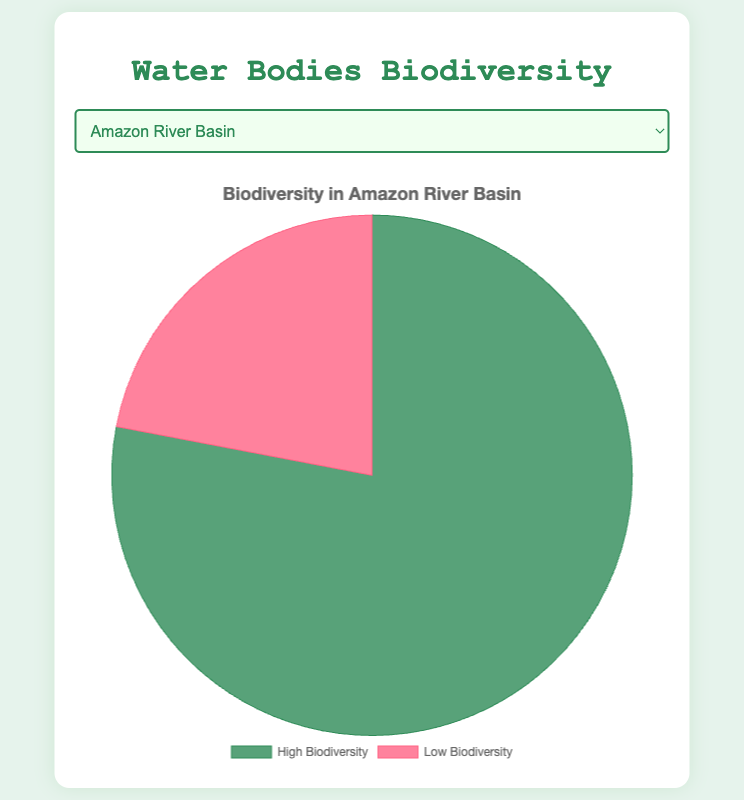Which water body has the highest percentage of high biodiversity? To determine this, compare the percentage of high biodiversity across all listed water bodies. The Coral Triangle has the highest percentage of high biodiversity at 89%.
Answer: Coral Triangle Which water bodies have less than 20% low biodiversity? Check the percentage of low biodiversity for each location. The Amazon River Basin, Great Barrier Reef, and Coral Triangle all have low biodiversity percentages under 20%.
Answer: Amazon River Basin, Great Barrier Reef, Coral Triangle How much higher is the percentage of high biodiversity in the Coral Triangle compared to the Mississippi River Delta? Subtract the percentage of high biodiversity in the Mississippi River Delta (52%) from that in the Coral Triangle (89%). The difference is 89% - 52% = 37%.
Answer: 37% What is the average percentage of high biodiversity across all water bodies? Add the percentages of high biodiversity for all locations and divide by the number of locations. (78% + 84% + 60% + 89% + 52%) / 5 = 72.6%.
Answer: 72.6% Which water body has the closest percentages of high and low biodiversity? The Mississippi River Delta has high biodiversity at 52% and low biodiversity at 48%, which are the closest in magnitude.
Answer: Mississippi River Delta Compare the sum of high biodiversity percentages in the Amazon River Basin and the Coral Triangle to the sum in the Great Barrier Reef and Lake Victoria. Which sum is greater? Calculate the sums: Amazon River Basin + Coral Triangle = 78% + 89% = 167%. Great Barrier Reef + Lake Victoria = 84% + 60% = 144%. The sum for Amazon River Basin and Coral Triangle is greater.
Answer: Amazon River Basin and Coral Triangle In which water body is the disparity between high and low biodiversity the smallest? Calculate the differences for each location. The Mississippi River Delta has the smallest disparity: 52% - 48% = 4%.
Answer: Mississippi River Delta 